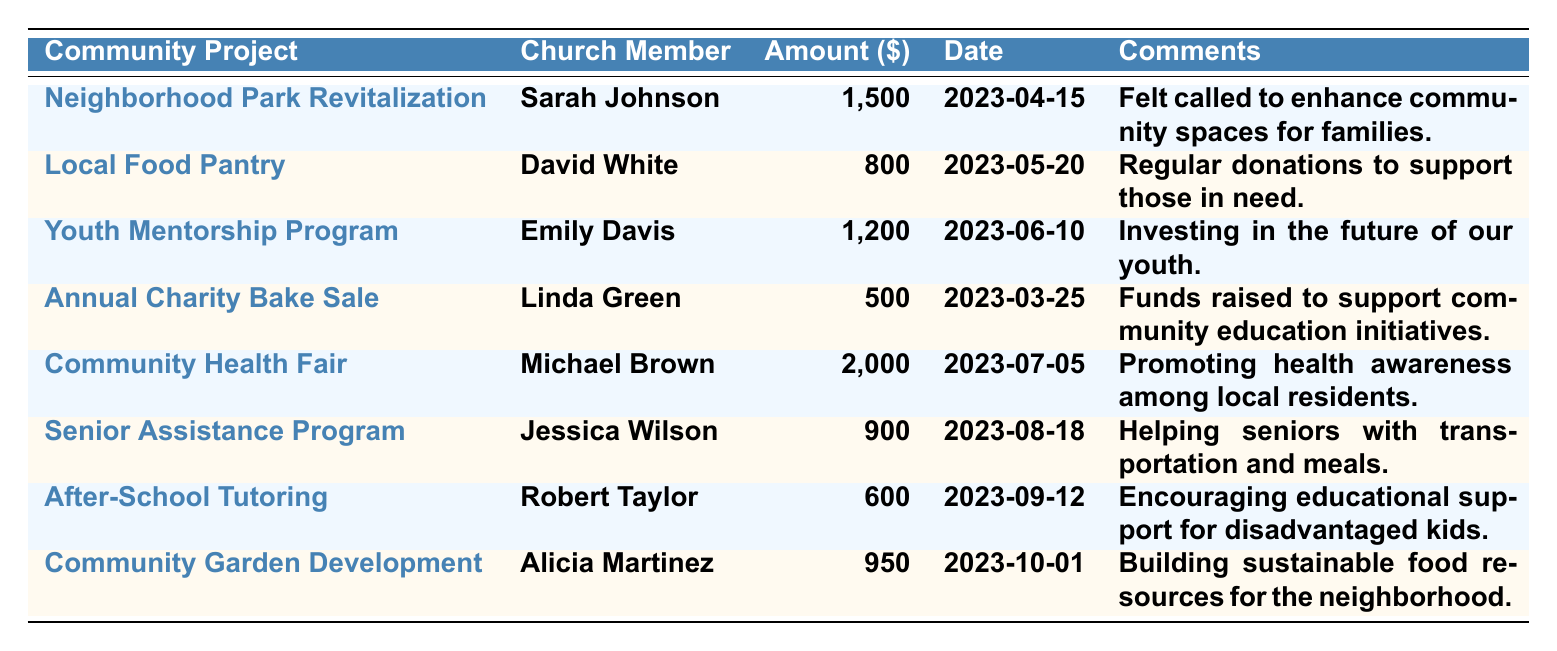What is the largest financial contribution made to a community project? The highest amount in the table is 2,000, contributed by Michael Brown for the Community Health Fair.
Answer: 2,000 Who contributed 900 dollars and what was the project about? Jessica Wilson contributed 900 dollars to the Senior Assistance Program, which helps seniors with transportation and meals.
Answer: Jessica Wilson, Senior Assistance Program How many contributions are equal to or exceed 1,000 dollars? The contributions that meet this criterion are: 1,500, 1,200, and 2,000, totaling 3 contributions.
Answer: 3 Is there a community project related to education in this table? Yes, the Annual Charity Bake Sale and the After-School Tutoring are both related to education initiatives.
Answer: Yes What is the total amount contributed to all community projects? Adding each contribution: 1,500 + 800 + 1,200 + 500 + 2,000 + 900 + 600 + 950 = 8,450.
Answer: 8,450 Which church member contributed to the project that helps local youth? Emily Davis contributed 1,200 dollars to the Youth Mentorship Program, which focuses on local youth.
Answer: Emily Davis How many projects received contributions of less than 1,000 dollars? The projects with contributions less than 1,000 dollars are the Annual Charity Bake Sale (500), After-School Tutoring (600), totaling 2 projects.
Answer: 2 Calculate the average contribution amount from the church members. The total contribution is 8,450 and there are 8 contributions. Dividing gives an average of 8,450 / 8 = 1,056.25.
Answer: 1,056.25 What percentage of contributions was made by Sarah Johnson? Sarah Johnson contributed 1,500 out of a total of 8,450. Calculating the percentage: (1,500 / 8,450) * 100 ≈ 17.74%.
Answer: 17.74% Which community project had the earliest contribution date? The earliest date is March 25, 2023, for the Annual Charity Bake Sale.
Answer: Annual Charity Bake Sale 